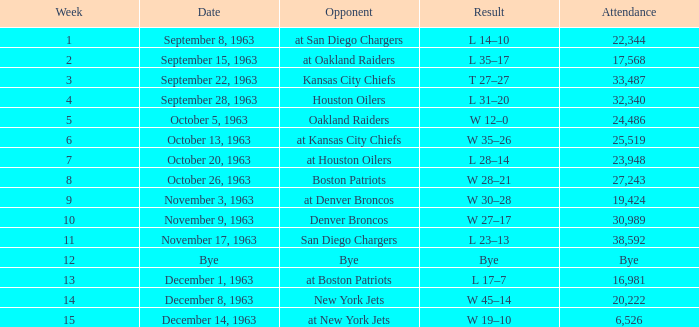Which rival has a score of w 19-10? At new york jets. 